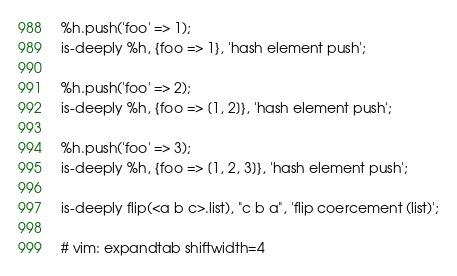Convert code to text. <code><loc_0><loc_0><loc_500><loc_500><_Perl_>%h.push('foo' => 1);
is-deeply %h, {foo => 1}, 'hash element push';

%h.push('foo' => 2);
is-deeply %h, {foo => [1, 2]}, 'hash element push';

%h.push('foo' => 3);
is-deeply %h, {foo => [1, 2, 3]}, 'hash element push';

is-deeply flip(<a b c>.list), "c b a", 'flip coercement (list)';

# vim: expandtab shiftwidth=4
</code> 